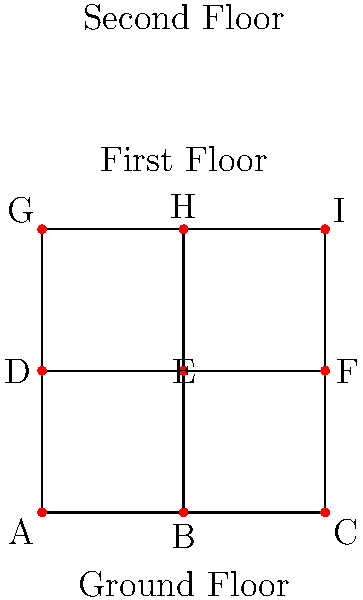As an architect designing a multi-story building, you need to determine the most efficient path for utilities (e.g., plumbing, electrical) through the structure. The building is represented as a graph where each node is a critical junction point, and edges represent possible paths for utilities. Given that the cost of running utilities between any two adjacent points is proportional to the Manhattan distance between them, what is the minimum total cost to connect all points if the cost between any two adjacent points is 5 units? To solve this problem, we need to find the minimum spanning tree (MST) of the given graph. The most efficient algorithm for this purpose is Kruskal's algorithm. Let's follow these steps:

1) First, we need to list all edges with their weights:
   All horizontal and vertical edges have a weight of 5 units.

2) Sort the edges by weight (in this case, all weights are equal):
   AB=BC=DE=EF=GH=HI=AD=BE=CF=DG=EH=FI = 5 units

3) Apply Kruskal's algorithm:
   a) Start with an empty set of edges.
   b) Add edges one by one, ensuring no cycles are formed.

4) Since all edges have the same weight, we can add them in any order as long as we don't create cycles. One possible MST is:
   AB, BC, AD, DE, EF, DG, GH, HI

5) Count the number of edges in the MST:
   There are 8 edges in total.

6) Calculate the total cost:
   Total cost = Number of edges × Cost per edge
               = 8 × 5 = 40 units

Therefore, the minimum total cost to connect all points is 40 units.
Answer: 40 units 